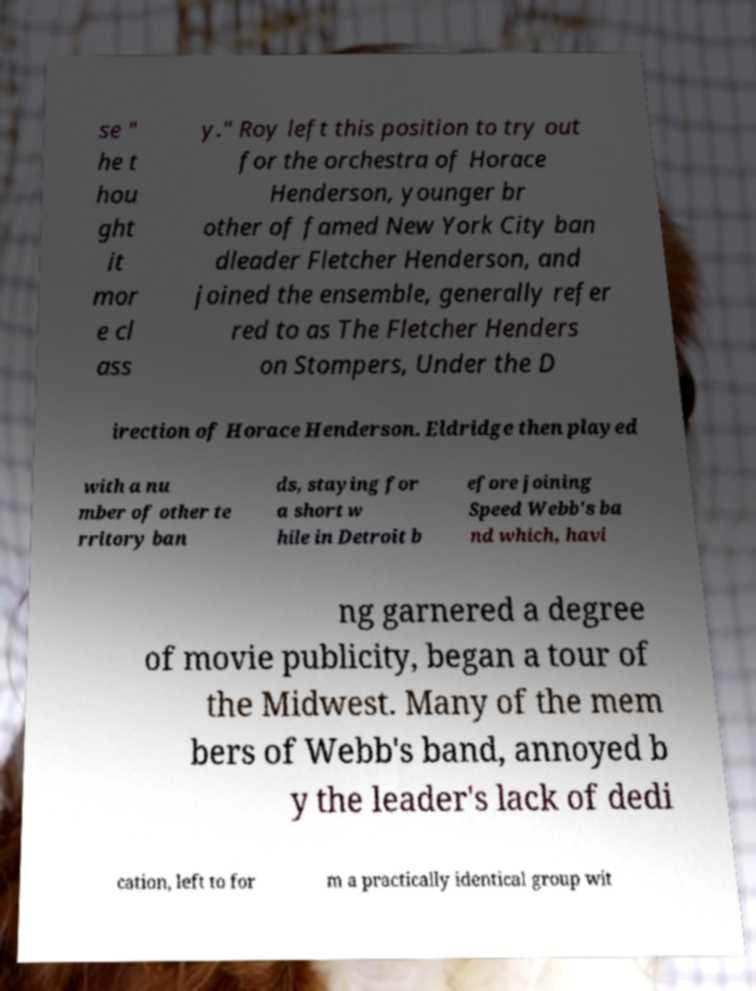I need the written content from this picture converted into text. Can you do that? se " he t hou ght it mor e cl ass y." Roy left this position to try out for the orchestra of Horace Henderson, younger br other of famed New York City ban dleader Fletcher Henderson, and joined the ensemble, generally refer red to as The Fletcher Henders on Stompers, Under the D irection of Horace Henderson. Eldridge then played with a nu mber of other te rritory ban ds, staying for a short w hile in Detroit b efore joining Speed Webb's ba nd which, havi ng garnered a degree of movie publicity, began a tour of the Midwest. Many of the mem bers of Webb's band, annoyed b y the leader's lack of dedi cation, left to for m a practically identical group wit 